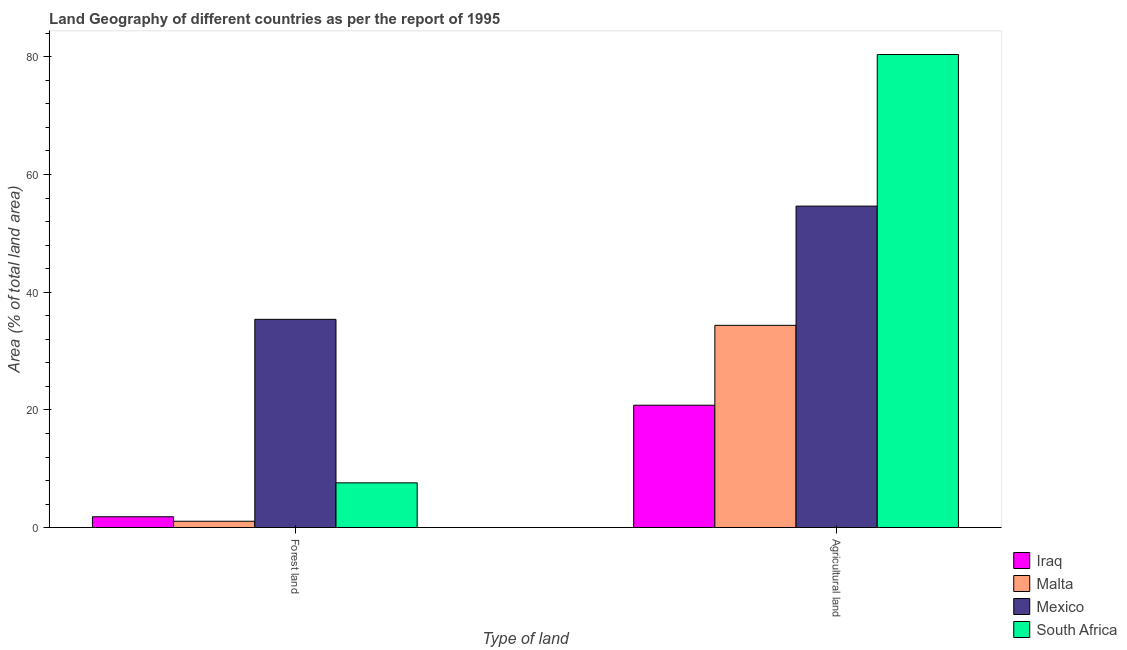How many bars are there on the 1st tick from the left?
Keep it short and to the point. 4. What is the label of the 1st group of bars from the left?
Your response must be concise. Forest land. What is the percentage of land area under agriculture in Malta?
Your answer should be compact. 34.38. Across all countries, what is the maximum percentage of land area under forests?
Ensure brevity in your answer.  35.4. Across all countries, what is the minimum percentage of land area under forests?
Ensure brevity in your answer.  1.09. In which country was the percentage of land area under forests maximum?
Ensure brevity in your answer.  Mexico. In which country was the percentage of land area under agriculture minimum?
Provide a short and direct response. Iraq. What is the total percentage of land area under forests in the graph?
Ensure brevity in your answer.  45.96. What is the difference between the percentage of land area under agriculture in South Africa and that in Malta?
Provide a short and direct response. 46.01. What is the difference between the percentage of land area under forests in Iraq and the percentage of land area under agriculture in Malta?
Make the answer very short. -32.52. What is the average percentage of land area under agriculture per country?
Ensure brevity in your answer.  47.55. What is the difference between the percentage of land area under agriculture and percentage of land area under forests in South Africa?
Offer a terse response. 72.77. What is the ratio of the percentage of land area under agriculture in Iraq to that in Malta?
Ensure brevity in your answer.  0.61. Is the percentage of land area under agriculture in South Africa less than that in Malta?
Ensure brevity in your answer.  No. In how many countries, is the percentage of land area under agriculture greater than the average percentage of land area under agriculture taken over all countries?
Ensure brevity in your answer.  2. What does the 4th bar from the left in Forest land represents?
Your answer should be compact. South Africa. What does the 4th bar from the right in Agricultural land represents?
Offer a very short reply. Iraq. How many bars are there?
Offer a very short reply. 8. Are all the bars in the graph horizontal?
Provide a short and direct response. No. How many countries are there in the graph?
Offer a terse response. 4. What is the difference between two consecutive major ticks on the Y-axis?
Ensure brevity in your answer.  20. Are the values on the major ticks of Y-axis written in scientific E-notation?
Your response must be concise. No. Does the graph contain any zero values?
Your answer should be very brief. No. Where does the legend appear in the graph?
Offer a terse response. Bottom right. How are the legend labels stacked?
Give a very brief answer. Vertical. What is the title of the graph?
Make the answer very short. Land Geography of different countries as per the report of 1995. What is the label or title of the X-axis?
Your answer should be compact. Type of land. What is the label or title of the Y-axis?
Offer a very short reply. Area (% of total land area). What is the Area (% of total land area) of Iraq in Forest land?
Give a very brief answer. 1.85. What is the Area (% of total land area) in Malta in Forest land?
Your answer should be very brief. 1.09. What is the Area (% of total land area) of Mexico in Forest land?
Offer a terse response. 35.4. What is the Area (% of total land area) in South Africa in Forest land?
Give a very brief answer. 7.62. What is the Area (% of total land area) in Iraq in Agricultural land?
Provide a succinct answer. 20.81. What is the Area (% of total land area) of Malta in Agricultural land?
Give a very brief answer. 34.38. What is the Area (% of total land area) in Mexico in Agricultural land?
Provide a short and direct response. 54.63. What is the Area (% of total land area) in South Africa in Agricultural land?
Offer a terse response. 80.39. Across all Type of land, what is the maximum Area (% of total land area) of Iraq?
Make the answer very short. 20.81. Across all Type of land, what is the maximum Area (% of total land area) in Malta?
Keep it short and to the point. 34.38. Across all Type of land, what is the maximum Area (% of total land area) in Mexico?
Make the answer very short. 54.63. Across all Type of land, what is the maximum Area (% of total land area) of South Africa?
Provide a short and direct response. 80.39. Across all Type of land, what is the minimum Area (% of total land area) in Iraq?
Offer a terse response. 1.85. Across all Type of land, what is the minimum Area (% of total land area) of Malta?
Ensure brevity in your answer.  1.09. Across all Type of land, what is the minimum Area (% of total land area) in Mexico?
Ensure brevity in your answer.  35.4. Across all Type of land, what is the minimum Area (% of total land area) of South Africa?
Make the answer very short. 7.62. What is the total Area (% of total land area) of Iraq in the graph?
Your answer should be compact. 22.66. What is the total Area (% of total land area) in Malta in the graph?
Offer a terse response. 35.47. What is the total Area (% of total land area) in Mexico in the graph?
Provide a short and direct response. 90.02. What is the total Area (% of total land area) of South Africa in the graph?
Give a very brief answer. 88.01. What is the difference between the Area (% of total land area) of Iraq in Forest land and that in Agricultural land?
Keep it short and to the point. -18.95. What is the difference between the Area (% of total land area) in Malta in Forest land and that in Agricultural land?
Offer a very short reply. -33.28. What is the difference between the Area (% of total land area) in Mexico in Forest land and that in Agricultural land?
Make the answer very short. -19.23. What is the difference between the Area (% of total land area) in South Africa in Forest land and that in Agricultural land?
Ensure brevity in your answer.  -72.77. What is the difference between the Area (% of total land area) in Iraq in Forest land and the Area (% of total land area) in Malta in Agricultural land?
Keep it short and to the point. -32.52. What is the difference between the Area (% of total land area) of Iraq in Forest land and the Area (% of total land area) of Mexico in Agricultural land?
Offer a very short reply. -52.77. What is the difference between the Area (% of total land area) of Iraq in Forest land and the Area (% of total land area) of South Africa in Agricultural land?
Your response must be concise. -78.54. What is the difference between the Area (% of total land area) in Malta in Forest land and the Area (% of total land area) in Mexico in Agricultural land?
Your answer should be compact. -53.53. What is the difference between the Area (% of total land area) of Malta in Forest land and the Area (% of total land area) of South Africa in Agricultural land?
Ensure brevity in your answer.  -79.3. What is the difference between the Area (% of total land area) of Mexico in Forest land and the Area (% of total land area) of South Africa in Agricultural land?
Provide a succinct answer. -44.99. What is the average Area (% of total land area) in Iraq per Type of land?
Give a very brief answer. 11.33. What is the average Area (% of total land area) of Malta per Type of land?
Provide a short and direct response. 17.73. What is the average Area (% of total land area) of Mexico per Type of land?
Offer a very short reply. 45.01. What is the average Area (% of total land area) of South Africa per Type of land?
Keep it short and to the point. 44. What is the difference between the Area (% of total land area) in Iraq and Area (% of total land area) in Malta in Forest land?
Provide a succinct answer. 0.76. What is the difference between the Area (% of total land area) of Iraq and Area (% of total land area) of Mexico in Forest land?
Keep it short and to the point. -33.54. What is the difference between the Area (% of total land area) in Iraq and Area (% of total land area) in South Africa in Forest land?
Your answer should be very brief. -5.76. What is the difference between the Area (% of total land area) in Malta and Area (% of total land area) in Mexico in Forest land?
Make the answer very short. -34.3. What is the difference between the Area (% of total land area) of Malta and Area (% of total land area) of South Africa in Forest land?
Your answer should be very brief. -6.52. What is the difference between the Area (% of total land area) of Mexico and Area (% of total land area) of South Africa in Forest land?
Offer a terse response. 27.78. What is the difference between the Area (% of total land area) of Iraq and Area (% of total land area) of Malta in Agricultural land?
Offer a very short reply. -13.57. What is the difference between the Area (% of total land area) of Iraq and Area (% of total land area) of Mexico in Agricultural land?
Your answer should be very brief. -33.82. What is the difference between the Area (% of total land area) in Iraq and Area (% of total land area) in South Africa in Agricultural land?
Ensure brevity in your answer.  -59.58. What is the difference between the Area (% of total land area) of Malta and Area (% of total land area) of Mexico in Agricultural land?
Keep it short and to the point. -20.25. What is the difference between the Area (% of total land area) of Malta and Area (% of total land area) of South Africa in Agricultural land?
Offer a terse response. -46.01. What is the difference between the Area (% of total land area) of Mexico and Area (% of total land area) of South Africa in Agricultural land?
Your answer should be compact. -25.76. What is the ratio of the Area (% of total land area) in Iraq in Forest land to that in Agricultural land?
Make the answer very short. 0.09. What is the ratio of the Area (% of total land area) in Malta in Forest land to that in Agricultural land?
Provide a succinct answer. 0.03. What is the ratio of the Area (% of total land area) of Mexico in Forest land to that in Agricultural land?
Offer a very short reply. 0.65. What is the ratio of the Area (% of total land area) in South Africa in Forest land to that in Agricultural land?
Your answer should be very brief. 0.09. What is the difference between the highest and the second highest Area (% of total land area) of Iraq?
Provide a succinct answer. 18.95. What is the difference between the highest and the second highest Area (% of total land area) in Malta?
Your response must be concise. 33.28. What is the difference between the highest and the second highest Area (% of total land area) in Mexico?
Give a very brief answer. 19.23. What is the difference between the highest and the second highest Area (% of total land area) in South Africa?
Ensure brevity in your answer.  72.77. What is the difference between the highest and the lowest Area (% of total land area) of Iraq?
Your response must be concise. 18.95. What is the difference between the highest and the lowest Area (% of total land area) in Malta?
Provide a succinct answer. 33.28. What is the difference between the highest and the lowest Area (% of total land area) in Mexico?
Your answer should be very brief. 19.23. What is the difference between the highest and the lowest Area (% of total land area) in South Africa?
Provide a short and direct response. 72.77. 